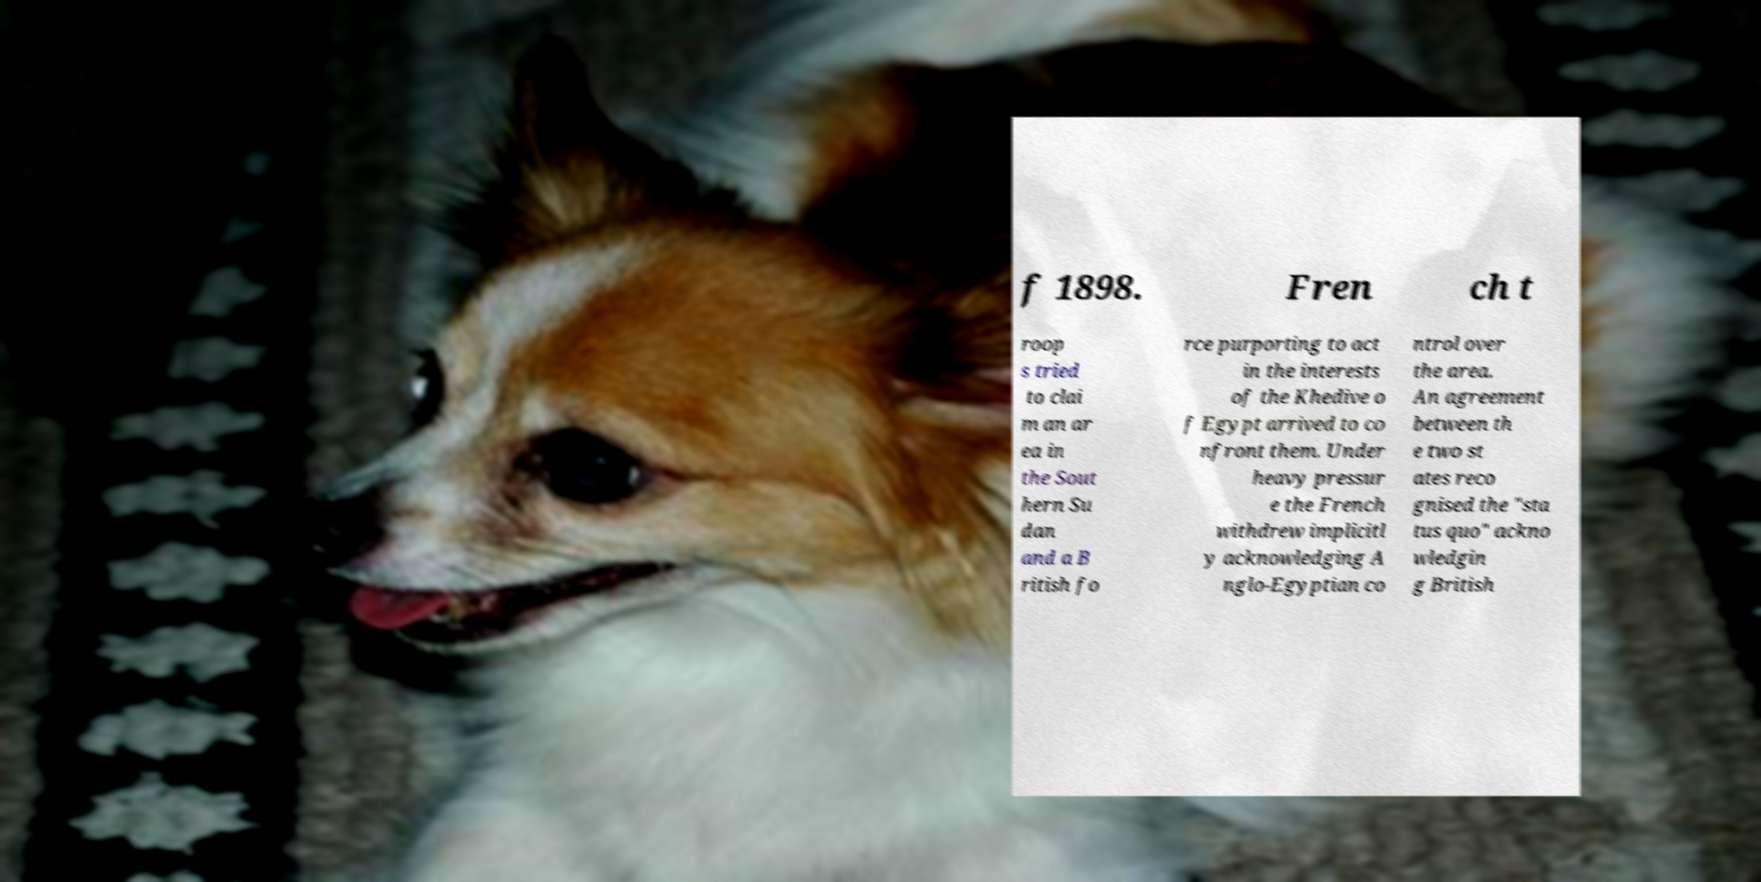There's text embedded in this image that I need extracted. Can you transcribe it verbatim? f 1898. Fren ch t roop s tried to clai m an ar ea in the Sout hern Su dan and a B ritish fo rce purporting to act in the interests of the Khedive o f Egypt arrived to co nfront them. Under heavy pressur e the French withdrew implicitl y acknowledging A nglo-Egyptian co ntrol over the area. An agreement between th e two st ates reco gnised the "sta tus quo" ackno wledgin g British 